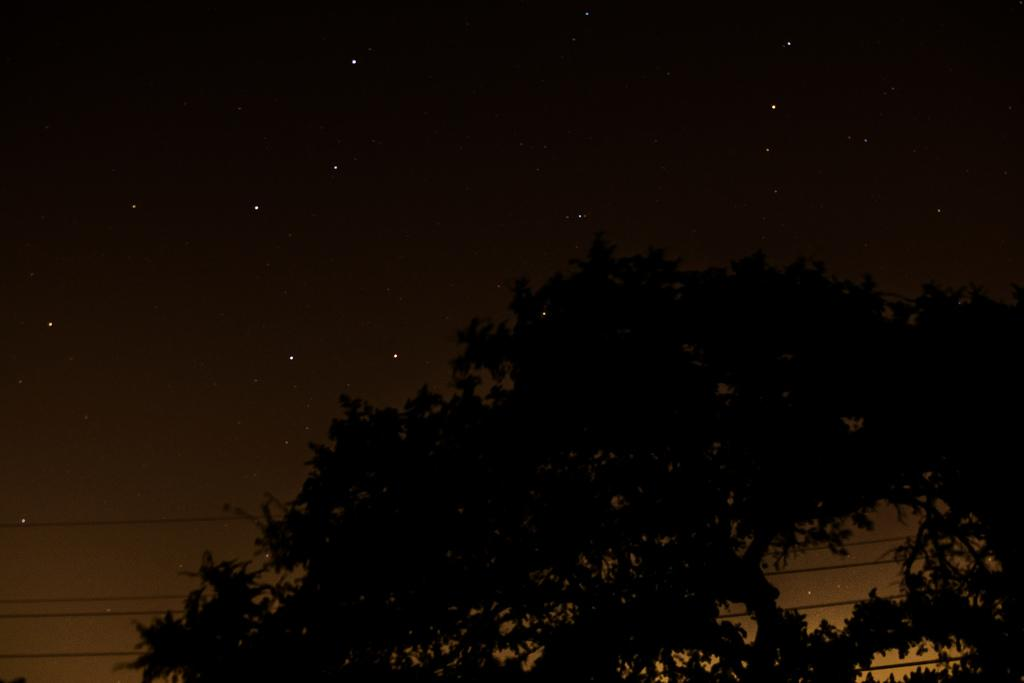What type of vegetation can be seen in the image? There are trees in the image. What is located at the bottom of the image? There are wires at the bottom of the image. What is visible in the background of the image? The background of the image includes the sky. What celestial objects can be seen in the sky? Stars are visible in the sky. What type of jelly is being used to create the stars in the image? There is no jelly present in the image, and the stars are not created using any jelly. What impulse led to the creation of the wires in the image? The image does not provide any information about the reason or impulse behind the presence of the wires. 